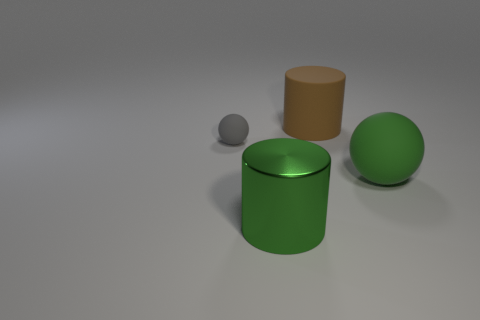What materials are the objects likely made of, based on their appearance? The cylinder and the sphere look like they're made of a reflective metal, possibly coated with a green paint, while the medium sized ball seems to be made of a matte material, like plastic or stone, and the small cube appears to have a paper or cardboard texture. 